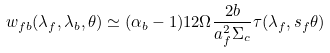Convert formula to latex. <formula><loc_0><loc_0><loc_500><loc_500>w _ { f b } ( { \lambda } _ { f } , { \lambda } _ { b } , \theta ) \simeq ( \alpha _ { b } - 1 ) 1 2 \Omega \frac { 2 b } { a _ { f } ^ { 2 } { \Sigma } _ { c } } \tau ( { \lambda } _ { f } , s _ { f } \theta )</formula> 